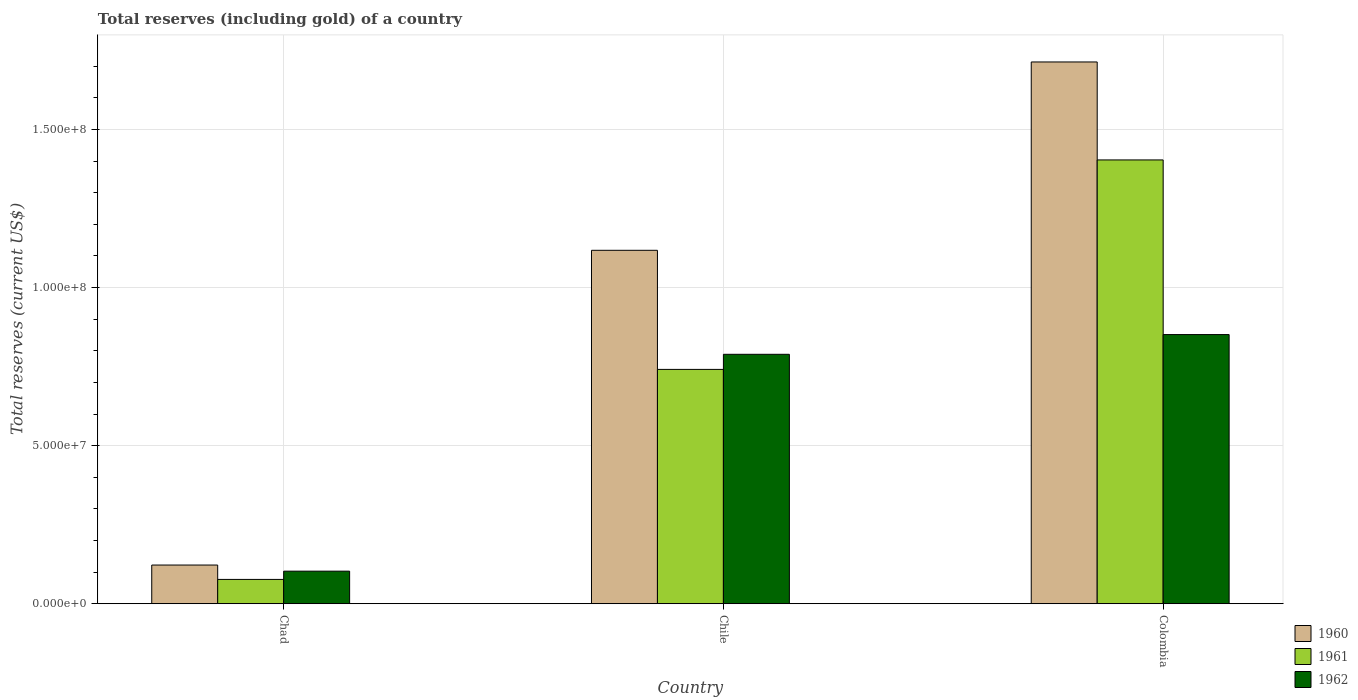How many different coloured bars are there?
Provide a short and direct response. 3. How many bars are there on the 1st tick from the right?
Offer a very short reply. 3. What is the total reserves (including gold) in 1961 in Chile?
Your answer should be compact. 7.41e+07. Across all countries, what is the maximum total reserves (including gold) in 1962?
Keep it short and to the point. 8.51e+07. Across all countries, what is the minimum total reserves (including gold) in 1961?
Offer a very short reply. 7.69e+06. In which country was the total reserves (including gold) in 1961 minimum?
Offer a very short reply. Chad. What is the total total reserves (including gold) in 1960 in the graph?
Keep it short and to the point. 2.95e+08. What is the difference between the total reserves (including gold) in 1961 in Chad and that in Colombia?
Ensure brevity in your answer.  -1.33e+08. What is the difference between the total reserves (including gold) in 1960 in Chile and the total reserves (including gold) in 1961 in Colombia?
Your answer should be very brief. -2.86e+07. What is the average total reserves (including gold) in 1962 per country?
Ensure brevity in your answer.  5.81e+07. What is the difference between the total reserves (including gold) of/in 1962 and total reserves (including gold) of/in 1961 in Chile?
Ensure brevity in your answer.  4.78e+06. What is the ratio of the total reserves (including gold) in 1960 in Chad to that in Colombia?
Your answer should be compact. 0.07. Is the total reserves (including gold) in 1962 in Chad less than that in Chile?
Your answer should be very brief. Yes. Is the difference between the total reserves (including gold) in 1962 in Chile and Colombia greater than the difference between the total reserves (including gold) in 1961 in Chile and Colombia?
Offer a terse response. Yes. What is the difference between the highest and the second highest total reserves (including gold) in 1961?
Ensure brevity in your answer.  -1.33e+08. What is the difference between the highest and the lowest total reserves (including gold) in 1961?
Provide a short and direct response. 1.33e+08. Is the sum of the total reserves (including gold) in 1961 in Chad and Chile greater than the maximum total reserves (including gold) in 1960 across all countries?
Keep it short and to the point. No. What does the 3rd bar from the left in Colombia represents?
Provide a short and direct response. 1962. What does the 3rd bar from the right in Chile represents?
Your answer should be very brief. 1960. How many bars are there?
Provide a succinct answer. 9. Are all the bars in the graph horizontal?
Your response must be concise. No. What is the difference between two consecutive major ticks on the Y-axis?
Your answer should be compact. 5.00e+07. Does the graph contain any zero values?
Keep it short and to the point. No. Does the graph contain grids?
Provide a short and direct response. Yes. How many legend labels are there?
Your response must be concise. 3. What is the title of the graph?
Your response must be concise. Total reserves (including gold) of a country. What is the label or title of the Y-axis?
Keep it short and to the point. Total reserves (current US$). What is the Total reserves (current US$) in 1960 in Chad?
Your answer should be very brief. 1.22e+07. What is the Total reserves (current US$) in 1961 in Chad?
Your answer should be very brief. 7.69e+06. What is the Total reserves (current US$) of 1962 in Chad?
Your answer should be very brief. 1.03e+07. What is the Total reserves (current US$) in 1960 in Chile?
Make the answer very short. 1.12e+08. What is the Total reserves (current US$) of 1961 in Chile?
Provide a succinct answer. 7.41e+07. What is the Total reserves (current US$) of 1962 in Chile?
Your answer should be very brief. 7.89e+07. What is the Total reserves (current US$) in 1960 in Colombia?
Give a very brief answer. 1.71e+08. What is the Total reserves (current US$) in 1961 in Colombia?
Offer a very short reply. 1.40e+08. What is the Total reserves (current US$) of 1962 in Colombia?
Give a very brief answer. 8.51e+07. Across all countries, what is the maximum Total reserves (current US$) in 1960?
Give a very brief answer. 1.71e+08. Across all countries, what is the maximum Total reserves (current US$) of 1961?
Your response must be concise. 1.40e+08. Across all countries, what is the maximum Total reserves (current US$) of 1962?
Give a very brief answer. 8.51e+07. Across all countries, what is the minimum Total reserves (current US$) in 1960?
Your answer should be compact. 1.22e+07. Across all countries, what is the minimum Total reserves (current US$) of 1961?
Keep it short and to the point. 7.69e+06. Across all countries, what is the minimum Total reserves (current US$) in 1962?
Provide a short and direct response. 1.03e+07. What is the total Total reserves (current US$) of 1960 in the graph?
Provide a short and direct response. 2.95e+08. What is the total Total reserves (current US$) of 1961 in the graph?
Provide a succinct answer. 2.22e+08. What is the total Total reserves (current US$) of 1962 in the graph?
Provide a short and direct response. 1.74e+08. What is the difference between the Total reserves (current US$) in 1960 in Chad and that in Chile?
Your answer should be very brief. -9.95e+07. What is the difference between the Total reserves (current US$) in 1961 in Chad and that in Chile?
Your answer should be compact. -6.64e+07. What is the difference between the Total reserves (current US$) of 1962 in Chad and that in Chile?
Your answer should be compact. -6.86e+07. What is the difference between the Total reserves (current US$) of 1960 in Chad and that in Colombia?
Ensure brevity in your answer.  -1.59e+08. What is the difference between the Total reserves (current US$) of 1961 in Chad and that in Colombia?
Offer a terse response. -1.33e+08. What is the difference between the Total reserves (current US$) in 1962 in Chad and that in Colombia?
Your response must be concise. -7.48e+07. What is the difference between the Total reserves (current US$) of 1960 in Chile and that in Colombia?
Your response must be concise. -5.96e+07. What is the difference between the Total reserves (current US$) of 1961 in Chile and that in Colombia?
Make the answer very short. -6.63e+07. What is the difference between the Total reserves (current US$) of 1962 in Chile and that in Colombia?
Make the answer very short. -6.24e+06. What is the difference between the Total reserves (current US$) in 1960 in Chad and the Total reserves (current US$) in 1961 in Chile?
Give a very brief answer. -6.19e+07. What is the difference between the Total reserves (current US$) in 1960 in Chad and the Total reserves (current US$) in 1962 in Chile?
Keep it short and to the point. -6.67e+07. What is the difference between the Total reserves (current US$) of 1961 in Chad and the Total reserves (current US$) of 1962 in Chile?
Offer a very short reply. -7.12e+07. What is the difference between the Total reserves (current US$) in 1960 in Chad and the Total reserves (current US$) in 1961 in Colombia?
Give a very brief answer. -1.28e+08. What is the difference between the Total reserves (current US$) in 1960 in Chad and the Total reserves (current US$) in 1962 in Colombia?
Your answer should be compact. -7.29e+07. What is the difference between the Total reserves (current US$) of 1961 in Chad and the Total reserves (current US$) of 1962 in Colombia?
Give a very brief answer. -7.74e+07. What is the difference between the Total reserves (current US$) of 1960 in Chile and the Total reserves (current US$) of 1961 in Colombia?
Provide a short and direct response. -2.86e+07. What is the difference between the Total reserves (current US$) in 1960 in Chile and the Total reserves (current US$) in 1962 in Colombia?
Provide a short and direct response. 2.67e+07. What is the difference between the Total reserves (current US$) in 1961 in Chile and the Total reserves (current US$) in 1962 in Colombia?
Give a very brief answer. -1.10e+07. What is the average Total reserves (current US$) in 1960 per country?
Offer a terse response. 9.85e+07. What is the average Total reserves (current US$) in 1961 per country?
Your answer should be very brief. 7.41e+07. What is the average Total reserves (current US$) of 1962 per country?
Offer a terse response. 5.81e+07. What is the difference between the Total reserves (current US$) of 1960 and Total reserves (current US$) of 1961 in Chad?
Offer a terse response. 4.55e+06. What is the difference between the Total reserves (current US$) of 1960 and Total reserves (current US$) of 1962 in Chad?
Keep it short and to the point. 1.94e+06. What is the difference between the Total reserves (current US$) in 1961 and Total reserves (current US$) in 1962 in Chad?
Your answer should be compact. -2.61e+06. What is the difference between the Total reserves (current US$) in 1960 and Total reserves (current US$) in 1961 in Chile?
Offer a terse response. 3.77e+07. What is the difference between the Total reserves (current US$) of 1960 and Total reserves (current US$) of 1962 in Chile?
Provide a succinct answer. 3.29e+07. What is the difference between the Total reserves (current US$) in 1961 and Total reserves (current US$) in 1962 in Chile?
Offer a terse response. -4.78e+06. What is the difference between the Total reserves (current US$) of 1960 and Total reserves (current US$) of 1961 in Colombia?
Offer a very short reply. 3.10e+07. What is the difference between the Total reserves (current US$) in 1960 and Total reserves (current US$) in 1962 in Colombia?
Your response must be concise. 8.62e+07. What is the difference between the Total reserves (current US$) in 1961 and Total reserves (current US$) in 1962 in Colombia?
Your response must be concise. 5.52e+07. What is the ratio of the Total reserves (current US$) of 1960 in Chad to that in Chile?
Make the answer very short. 0.11. What is the ratio of the Total reserves (current US$) in 1961 in Chad to that in Chile?
Give a very brief answer. 0.1. What is the ratio of the Total reserves (current US$) of 1962 in Chad to that in Chile?
Offer a very short reply. 0.13. What is the ratio of the Total reserves (current US$) in 1960 in Chad to that in Colombia?
Provide a short and direct response. 0.07. What is the ratio of the Total reserves (current US$) of 1961 in Chad to that in Colombia?
Give a very brief answer. 0.05. What is the ratio of the Total reserves (current US$) in 1962 in Chad to that in Colombia?
Offer a terse response. 0.12. What is the ratio of the Total reserves (current US$) in 1960 in Chile to that in Colombia?
Give a very brief answer. 0.65. What is the ratio of the Total reserves (current US$) of 1961 in Chile to that in Colombia?
Give a very brief answer. 0.53. What is the ratio of the Total reserves (current US$) in 1962 in Chile to that in Colombia?
Keep it short and to the point. 0.93. What is the difference between the highest and the second highest Total reserves (current US$) of 1960?
Your response must be concise. 5.96e+07. What is the difference between the highest and the second highest Total reserves (current US$) in 1961?
Give a very brief answer. 6.63e+07. What is the difference between the highest and the second highest Total reserves (current US$) in 1962?
Provide a succinct answer. 6.24e+06. What is the difference between the highest and the lowest Total reserves (current US$) of 1960?
Offer a very short reply. 1.59e+08. What is the difference between the highest and the lowest Total reserves (current US$) in 1961?
Offer a terse response. 1.33e+08. What is the difference between the highest and the lowest Total reserves (current US$) in 1962?
Your response must be concise. 7.48e+07. 